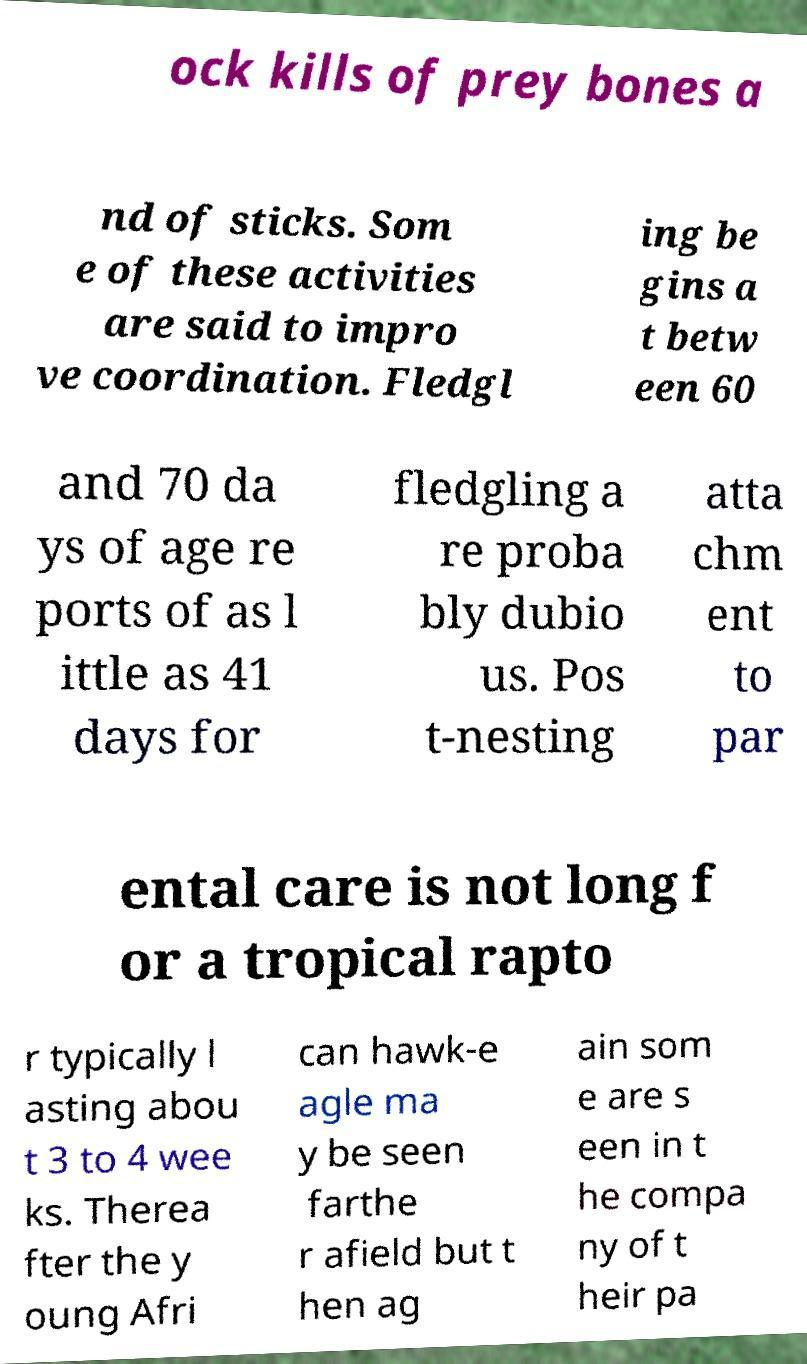Can you accurately transcribe the text from the provided image for me? ock kills of prey bones a nd of sticks. Som e of these activities are said to impro ve coordination. Fledgl ing be gins a t betw een 60 and 70 da ys of age re ports of as l ittle as 41 days for fledgling a re proba bly dubio us. Pos t-nesting atta chm ent to par ental care is not long f or a tropical rapto r typically l asting abou t 3 to 4 wee ks. Therea fter the y oung Afri can hawk-e agle ma y be seen farthe r afield but t hen ag ain som e are s een in t he compa ny of t heir pa 